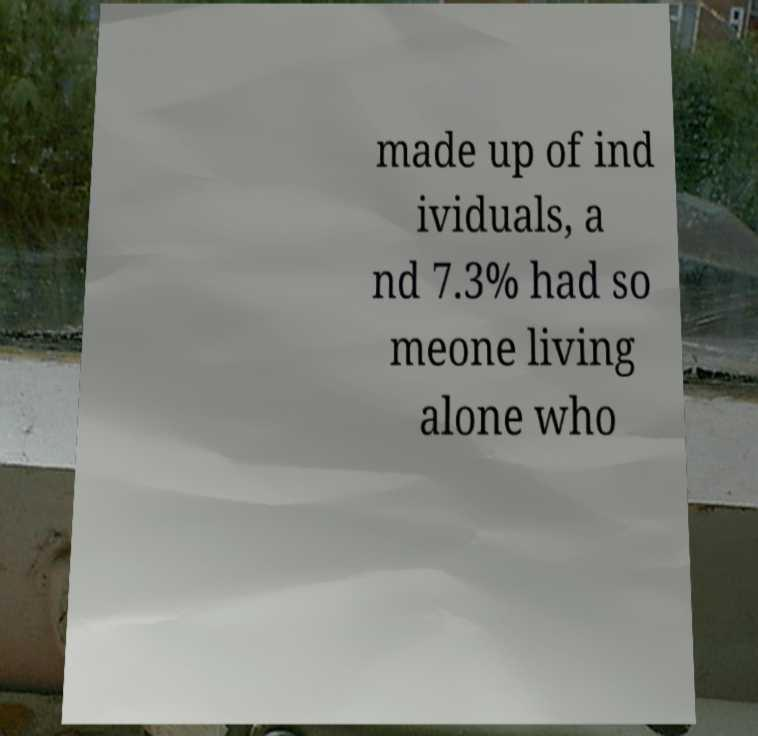Can you read and provide the text displayed in the image?This photo seems to have some interesting text. Can you extract and type it out for me? made up of ind ividuals, a nd 7.3% had so meone living alone who 